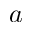<formula> <loc_0><loc_0><loc_500><loc_500>a</formula> 